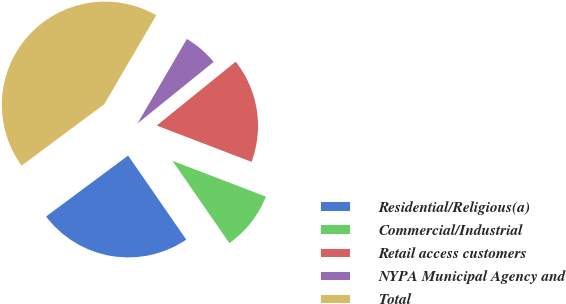<chart> <loc_0><loc_0><loc_500><loc_500><pie_chart><fcel>Residential/Religious(a)<fcel>Commercial/Industrial<fcel>Retail access customers<fcel>NYPA Municipal Agency and<fcel>Total<nl><fcel>24.46%<fcel>9.55%<fcel>16.64%<fcel>5.77%<fcel>43.58%<nl></chart> 